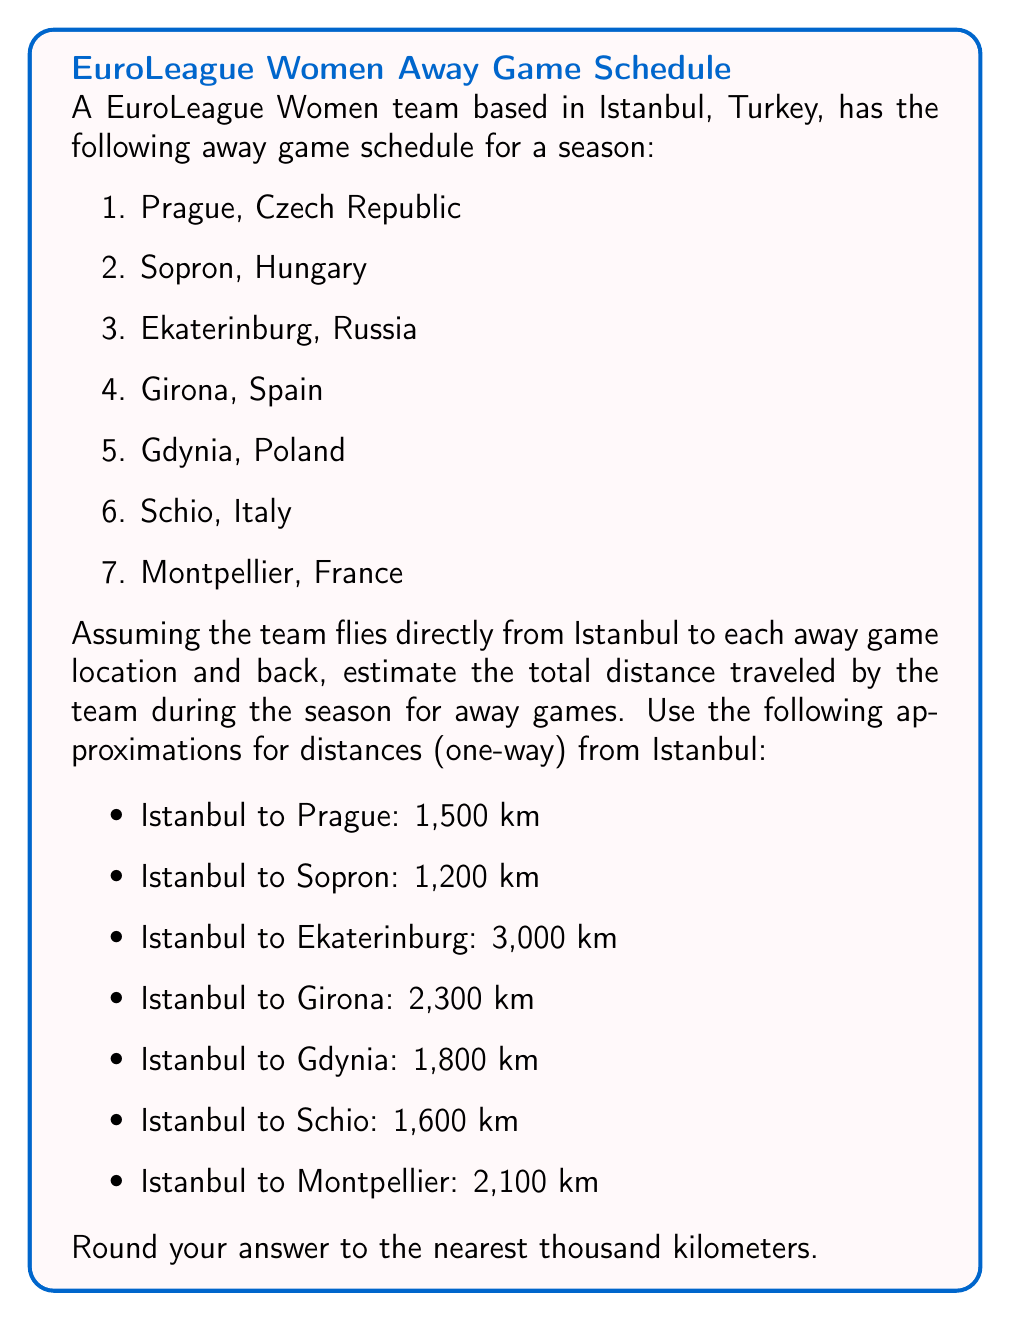Give your solution to this math problem. To solve this problem, we need to follow these steps:

1. Calculate the round-trip distance for each away game.
2. Sum up all the round-trip distances.
3. Round the total to the nearest thousand kilometers.

Let's calculate the round-trip distance for each game:

1. Istanbul to Prague: $2 \times 1,500 = 3,000$ km
2. Istanbul to Sopron: $2 \times 1,200 = 2,400$ km
3. Istanbul to Ekaterinburg: $2 \times 3,000 = 6,000$ km
4. Istanbul to Girona: $2 \times 2,300 = 4,600$ km
5. Istanbul to Gdynia: $2 \times 1,800 = 3,600$ km
6. Istanbul to Schio: $2 \times 1,600 = 3,200$ km
7. Istanbul to Montpellier: $2 \times 2,100 = 4,200$ km

Now, let's sum up all the round-trip distances:

$$\begin{align}
\text{Total distance} &= 3,000 + 2,400 + 6,000 + 4,600 + 3,600 + 3,200 + 4,200 \\
&= 27,000 \text{ km}
\end{align}$$

The total distance is already rounded to the nearest thousand kilometers, so no further rounding is necessary.
Answer: 27,000 km 